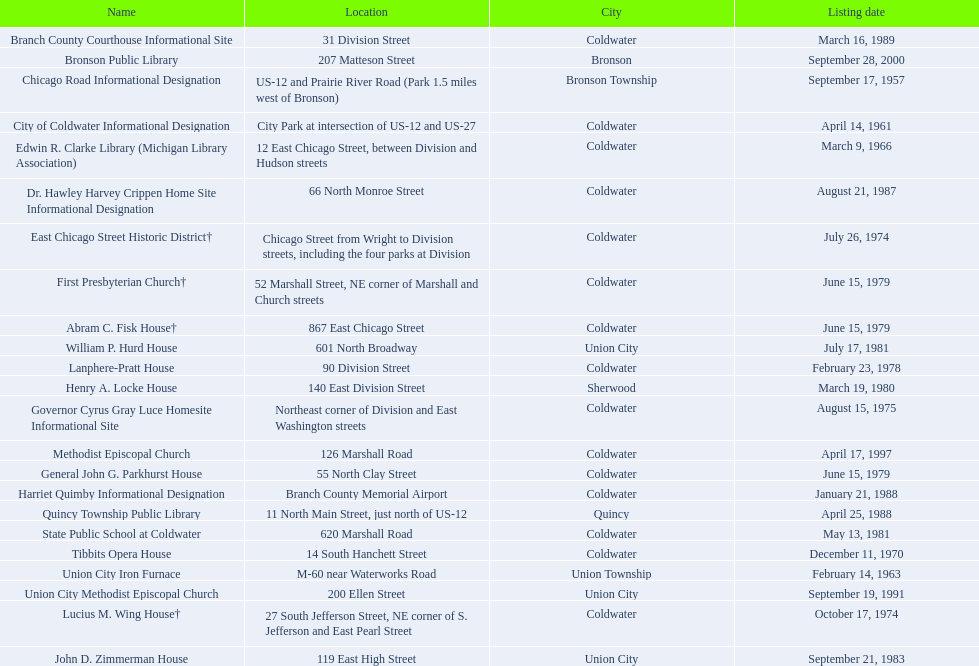How many historic sites are listed in coldwater? 15. 